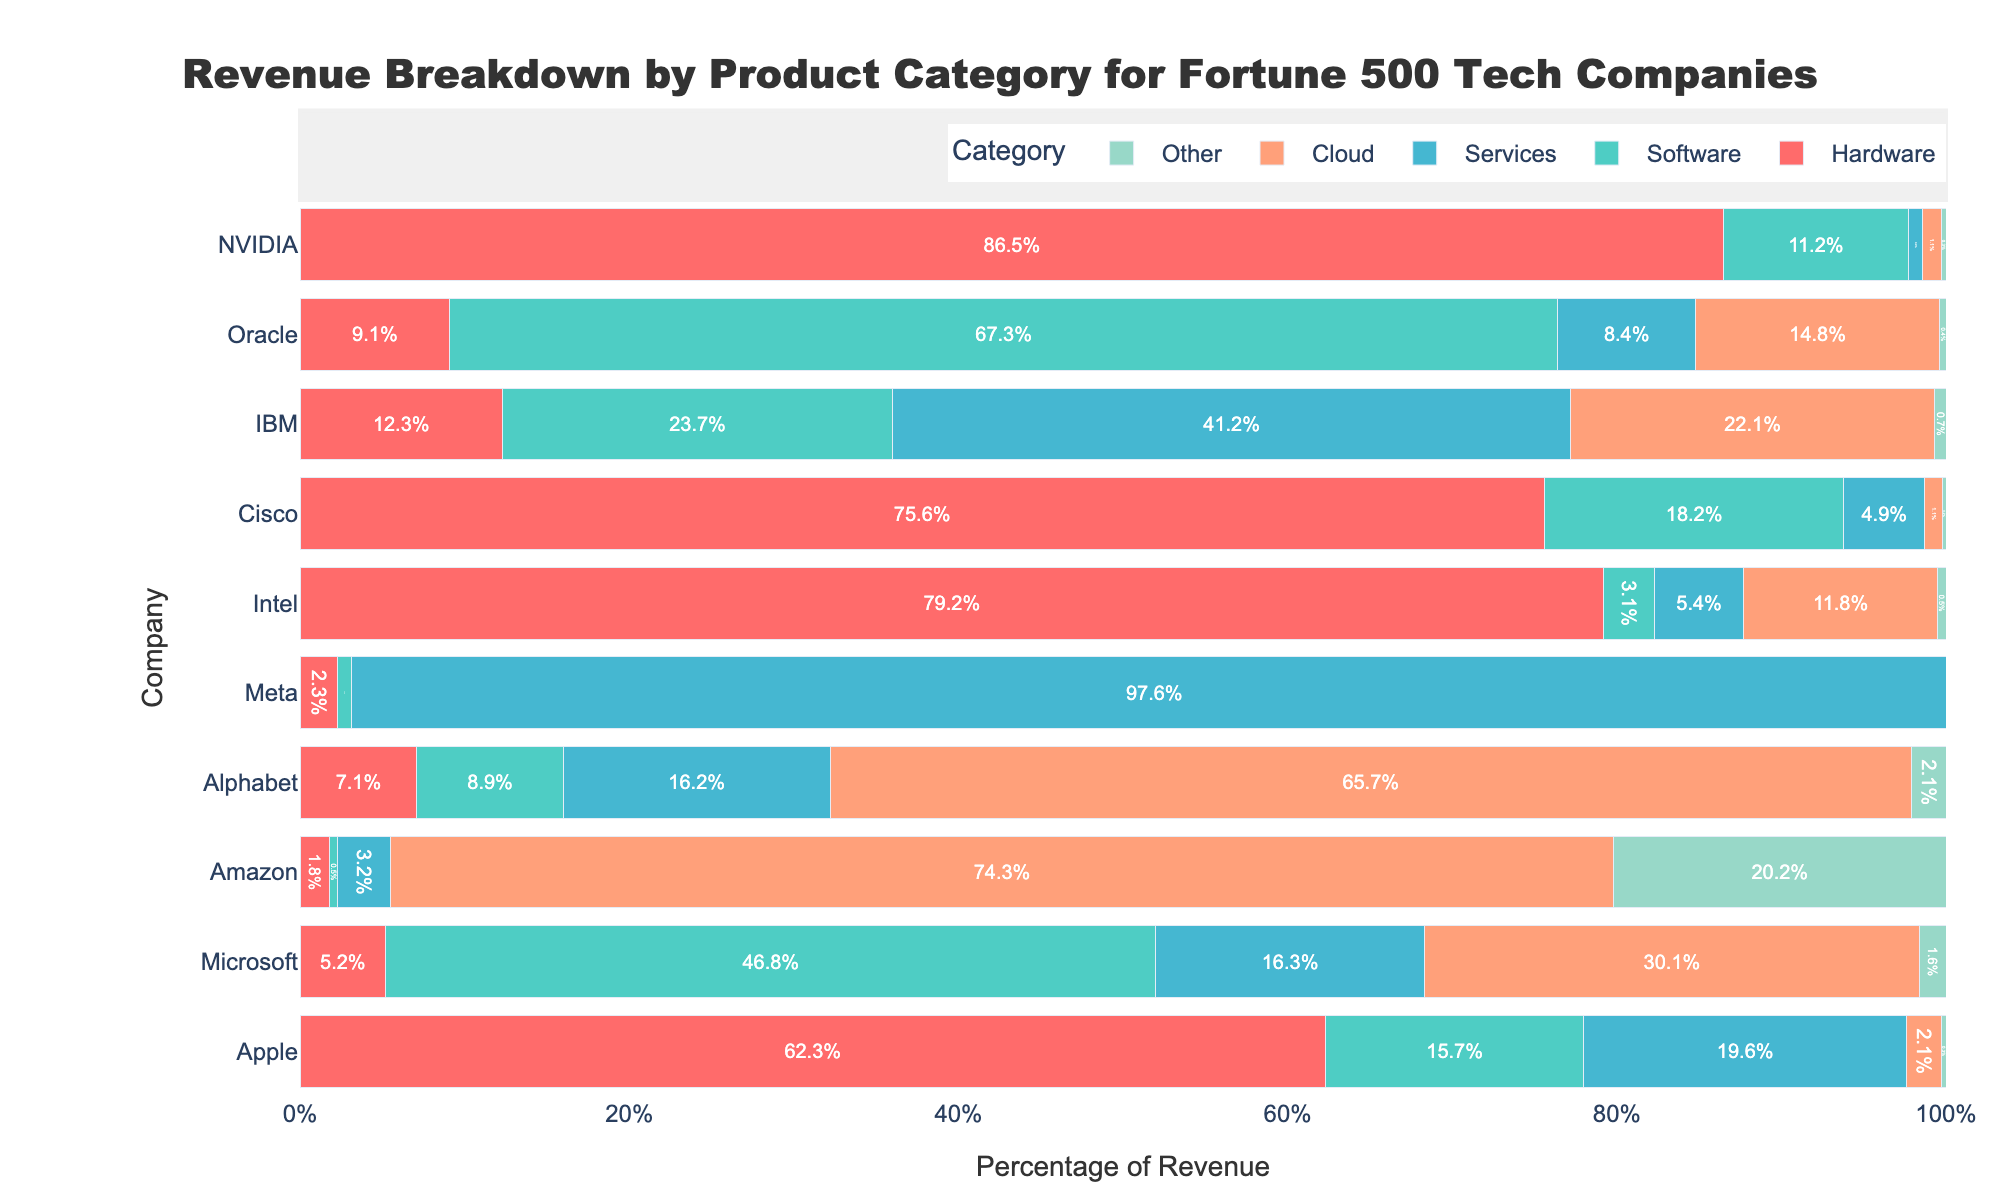What percentage of Amazon's revenue comes from the Cloud category? From the bar chart, Amazon's percentage of revenue from the Cloud category is 74.3%, as indicated by the length of the corresponding bar.
Answer: 74.3% Which company has the highest percentage of revenue from Hardware, and what is that percentage? The chart shows that NVIDIA has the longest bar in the Hardware category, indicating it has the highest percentage. The exact value for NVIDIA in Hardware is 86.5%.
Answer: NVIDIA with 86.5% What is the total percentage of revenue for Software and Cloud categories combined for Microsoft? Add the percentage of revenue from Software (46.8%) and Cloud (30.1%) for Microsoft. The total is 46.8% + 30.1% = 76.9%.
Answer: 76.9% Which company has the smallest contribution to its revenue from the Services category, and what is the percentage? The chart shows Amazon has the smallest bar in the Services category, which is 3.2%.
Answer: Amazon with 3.2% Compare Alphabet's and IBM's revenue percentages for the Cloud category. Which is higher and by how much? Alphabet's revenue from Cloud is 65.7% and IBM's is 22.1%. The difference is 65.7% - 22.1% = 43.6%, with Alphabet having the higher percentage.
Answer: Alphabet by 43.6% Visually, which company has the most evenly distributed revenue across all categories? IBM's bars appear relatively even across Hardware, Software, Services, and Cloud, indicating a more balanced distribution compared to other companies.
Answer: IBM If you combine the 'Other' category for all companies, what is the total percentage? Sum the 'Other' categories: 0.3% (Apple) + 1.6% (Microsoft) + 20.2% (Amazon) + 2.1% (Alphabet) + 0.3% (Meta) + 0.5% (Intel) + 0.2% (Cisco) + 0.7% (IBM) + 0.4% (Oracle) + 0.3% (NVIDIA) = 26.6%.
Answer: 26.6% Which two companies have the highest revenue percentage from the Services category, and what are those percentages? From the chart, Meta has the highest with 97.6%, followed by IBM with 41.2% in the Services category.
Answer: Meta (97.6%) and IBM (41.2%) How does the percentage of revenue from Software for Oracle compare to that of Cisco? Oracle's revenue percentage from Software is 67.3%, and Cisco's is 18.2%. Oracle's percentage is therefore higher by 67.3% - 18.2% = 49.1%.
Answer: Oracle by 49.1% Among the companies, who has the least percentage of revenue from the Hardware category, and what is that percentage? The chart indicates that Amazon has the smallest percentage of revenue from Hardware, which is 1.8%.
Answer: Amazon with 1.8% 